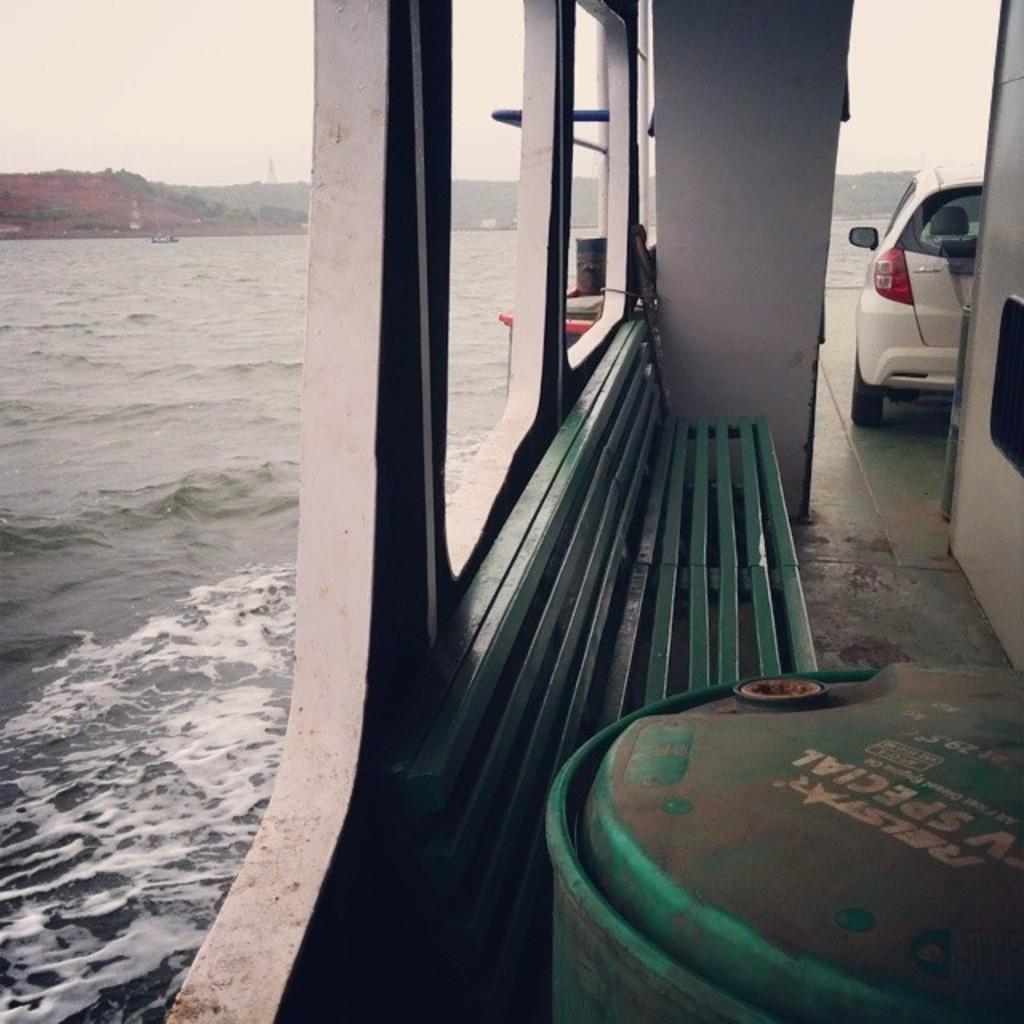In one or two sentences, can you explain what this image depicts? In this image I can see a boat on the water surface. There is a car in the boat. In the background I can see few mountains. I can see a chair. 